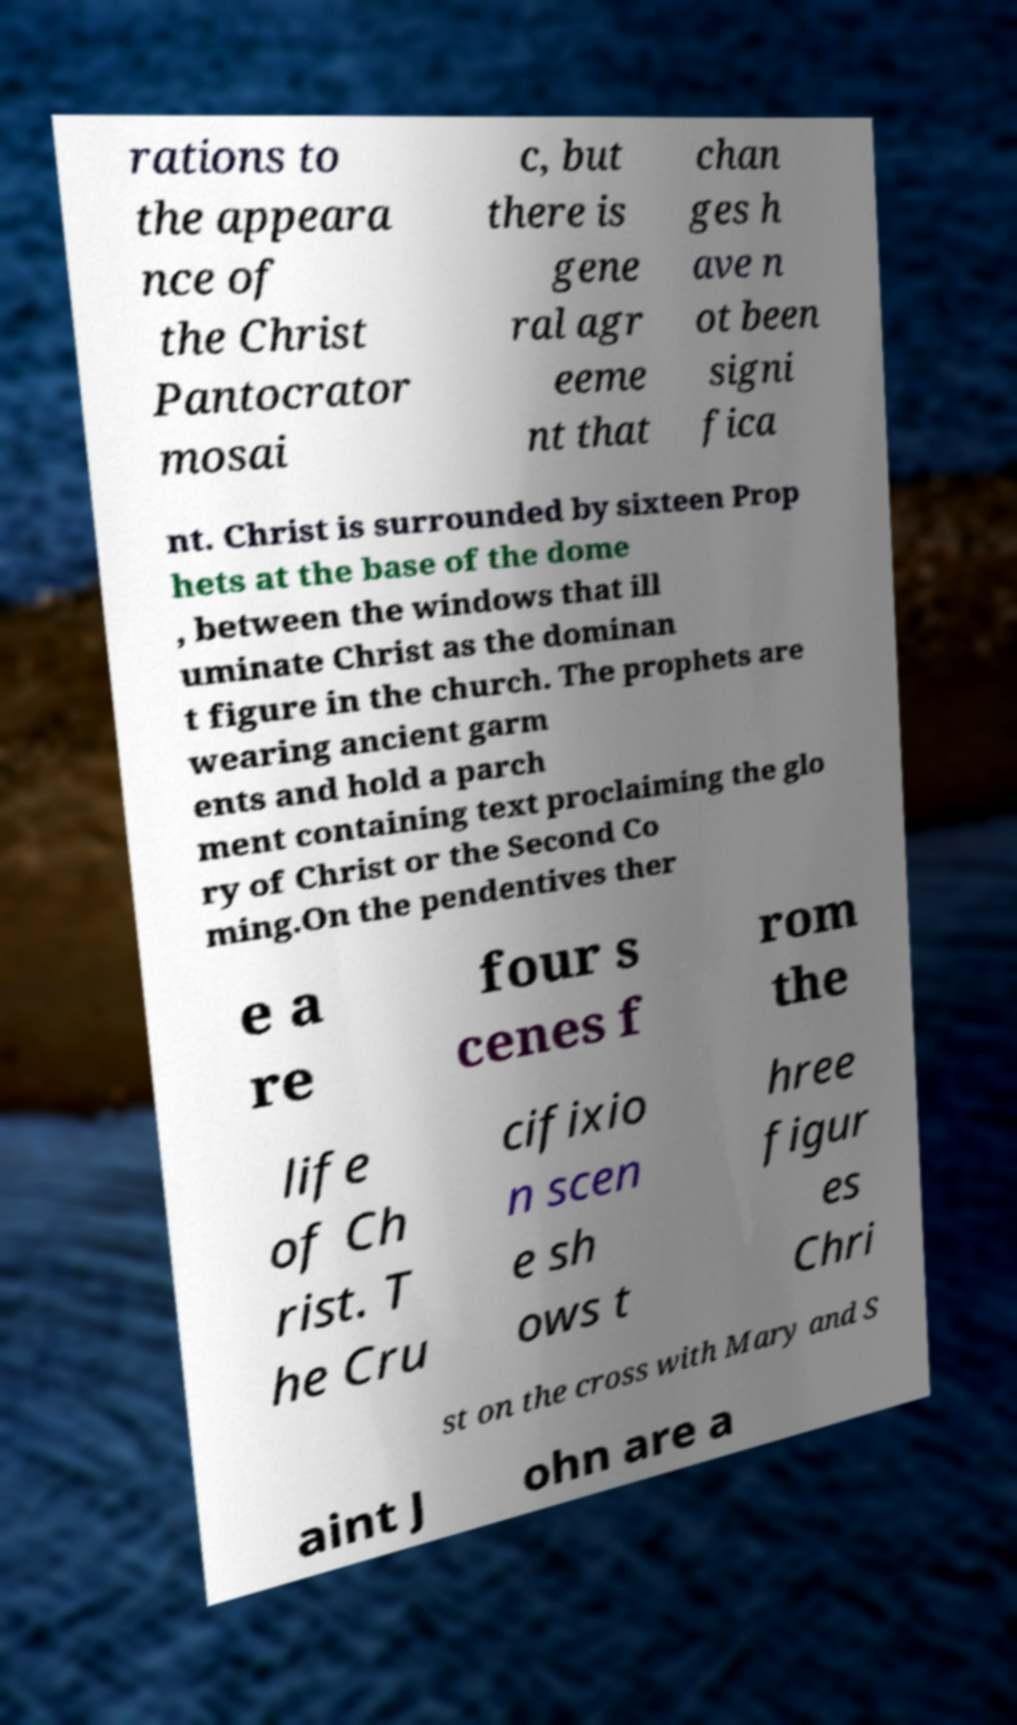Please identify and transcribe the text found in this image. rations to the appeara nce of the Christ Pantocrator mosai c, but there is gene ral agr eeme nt that chan ges h ave n ot been signi fica nt. Christ is surrounded by sixteen Prop hets at the base of the dome , between the windows that ill uminate Christ as the dominan t figure in the church. The prophets are wearing ancient garm ents and hold a parch ment containing text proclaiming the glo ry of Christ or the Second Co ming.On the pendentives ther e a re four s cenes f rom the life of Ch rist. T he Cru cifixio n scen e sh ows t hree figur es Chri st on the cross with Mary and S aint J ohn are a 